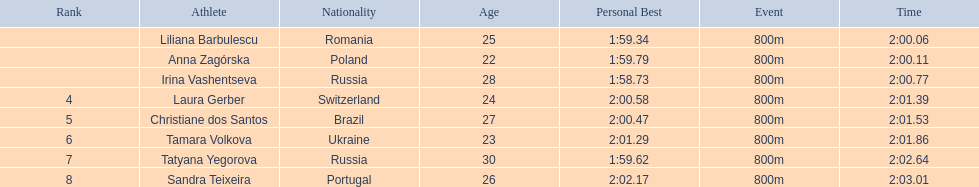Who were the athletes? Liliana Barbulescu, 2:00.06, Anna Zagórska, 2:00.11, Irina Vashentseva, 2:00.77, Laura Gerber, 2:01.39, Christiane dos Santos, 2:01.53, Tamara Volkova, 2:01.86, Tatyana Yegorova, 2:02.64, Sandra Teixeira, 2:03.01. Who received 2nd place? Anna Zagórska, 2:00.11. What was her time? 2:00.11. 